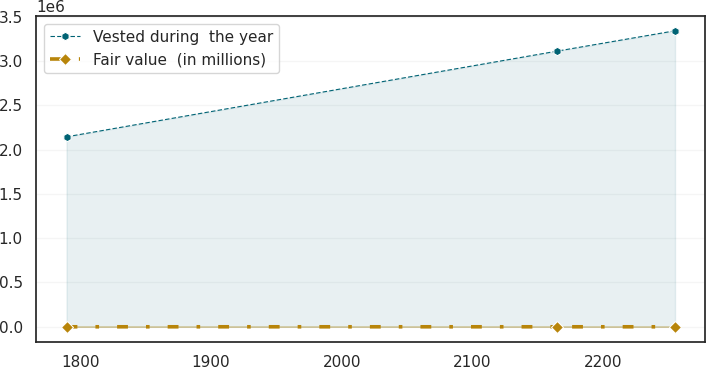Convert chart to OTSL. <chart><loc_0><loc_0><loc_500><loc_500><line_chart><ecel><fcel>Vested during  the year<fcel>Fair value  (in millions)<nl><fcel>1789.62<fcel>2.14461e+06<fcel>74.62<nl><fcel>2164.43<fcel>3.11132e+06<fcel>60.38<nl><fcel>2254.81<fcel>3.3417e+06<fcel>61.8<nl></chart> 